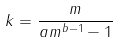Convert formula to latex. <formula><loc_0><loc_0><loc_500><loc_500>k = \frac { m } { a m ^ { b - 1 } - 1 }</formula> 